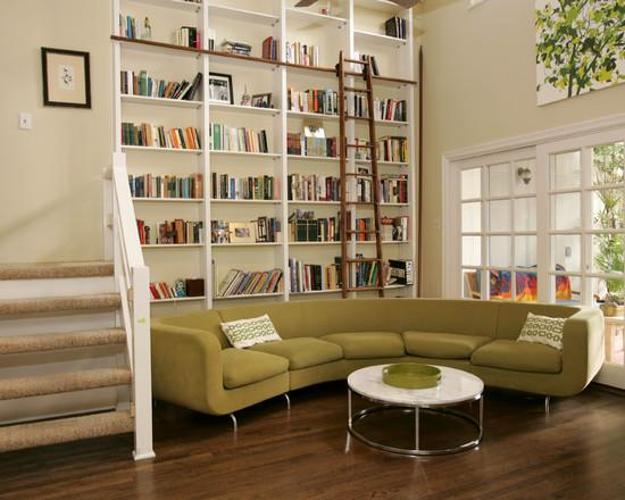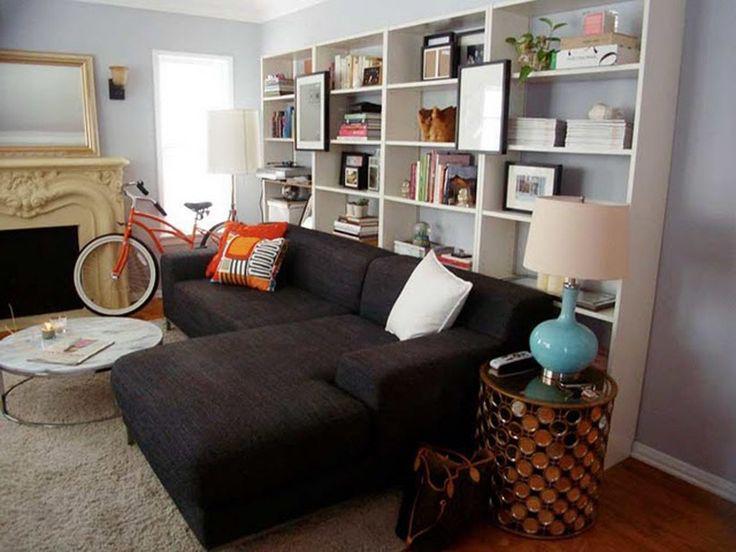The first image is the image on the left, the second image is the image on the right. Considering the images on both sides, is "The bookshelf in the image on the left is near a window." valid? Answer yes or no. Yes. 